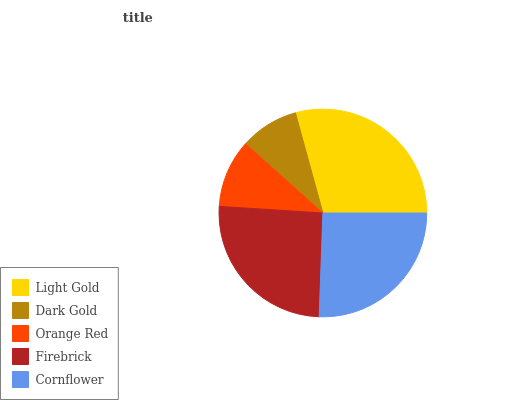Is Dark Gold the minimum?
Answer yes or no. Yes. Is Light Gold the maximum?
Answer yes or no. Yes. Is Orange Red the minimum?
Answer yes or no. No. Is Orange Red the maximum?
Answer yes or no. No. Is Orange Red greater than Dark Gold?
Answer yes or no. Yes. Is Dark Gold less than Orange Red?
Answer yes or no. Yes. Is Dark Gold greater than Orange Red?
Answer yes or no. No. Is Orange Red less than Dark Gold?
Answer yes or no. No. Is Firebrick the high median?
Answer yes or no. Yes. Is Firebrick the low median?
Answer yes or no. Yes. Is Dark Gold the high median?
Answer yes or no. No. Is Cornflower the low median?
Answer yes or no. No. 